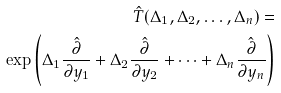Convert formula to latex. <formula><loc_0><loc_0><loc_500><loc_500>\hat { T } ( \Delta _ { 1 } , \Delta _ { 2 } , \dots , \Delta _ { n } ) = \\ \exp \left ( \Delta _ { 1 } \frac { \hat { \partial } } { \partial y _ { 1 } } + \Delta _ { 2 } \frac { \hat { \partial } } { \partial y _ { 2 } } + \dots + \Delta _ { n } \frac { \hat { \partial } } { \partial y _ { n } } \right )</formula> 